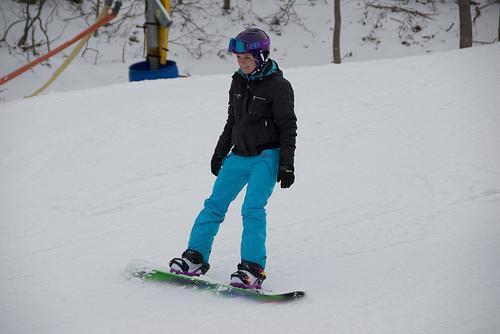How many women are in the picture?
Give a very brief answer. 1. 